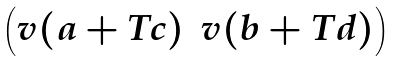<formula> <loc_0><loc_0><loc_500><loc_500>\begin{pmatrix} v ( a + T c ) & v ( b + T d ) \end{pmatrix}</formula> 